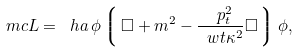<formula> <loc_0><loc_0><loc_500><loc_500>\ m c { L } = \ h a \, \phi \left \lgroup \, \Box + m ^ { 2 } - \frac { \ p _ { t } ^ { 2 } } { \ w t { \kappa } ^ { 2 } } \Box \, \right \rgroup \phi ,</formula> 